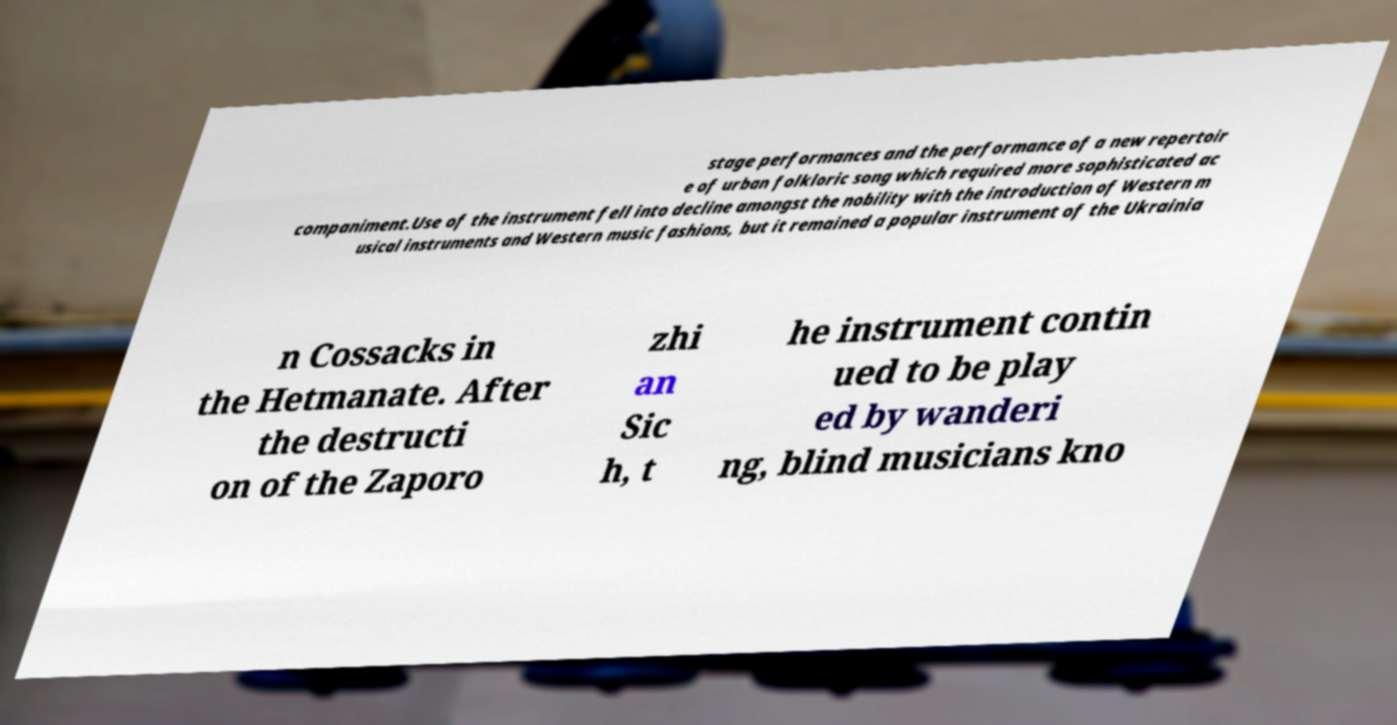Please identify and transcribe the text found in this image. stage performances and the performance of a new repertoir e of urban folkloric song which required more sophisticated ac companiment.Use of the instrument fell into decline amongst the nobility with the introduction of Western m usical instruments and Western music fashions, but it remained a popular instrument of the Ukrainia n Cossacks in the Hetmanate. After the destructi on of the Zaporo zhi an Sic h, t he instrument contin ued to be play ed by wanderi ng, blind musicians kno 